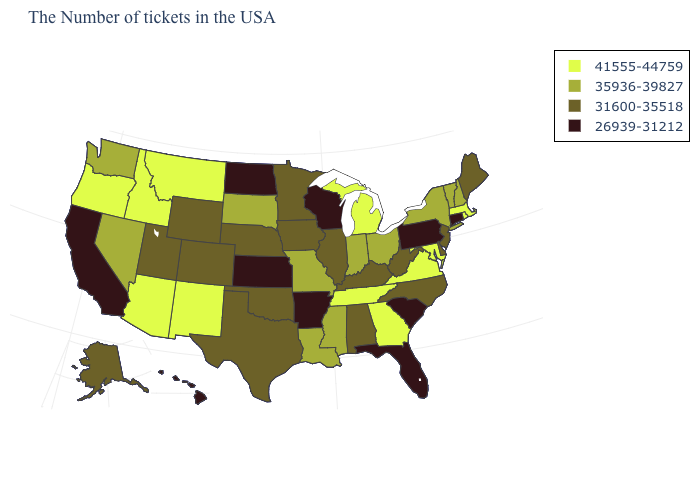Among the states that border Wyoming , does Utah have the lowest value?
Give a very brief answer. Yes. What is the highest value in the West ?
Give a very brief answer. 41555-44759. Name the states that have a value in the range 26939-31212?
Short answer required. Connecticut, Pennsylvania, South Carolina, Florida, Wisconsin, Arkansas, Kansas, North Dakota, California, Hawaii. What is the value of Idaho?
Concise answer only. 41555-44759. Does Wisconsin have the lowest value in the USA?
Keep it brief. Yes. What is the highest value in the USA?
Concise answer only. 41555-44759. Does Kansas have the lowest value in the MidWest?
Quick response, please. Yes. Does Rhode Island have the same value as New York?
Keep it brief. No. Does Florida have the lowest value in the USA?
Quick response, please. Yes. What is the value of Pennsylvania?
Be succinct. 26939-31212. Name the states that have a value in the range 31600-35518?
Concise answer only. Maine, New Jersey, Delaware, North Carolina, West Virginia, Kentucky, Alabama, Illinois, Minnesota, Iowa, Nebraska, Oklahoma, Texas, Wyoming, Colorado, Utah, Alaska. Among the states that border Texas , which have the highest value?
Short answer required. New Mexico. What is the highest value in states that border Washington?
Answer briefly. 41555-44759. What is the highest value in states that border Wisconsin?
Quick response, please. 41555-44759. What is the value of Indiana?
Keep it brief. 35936-39827. 